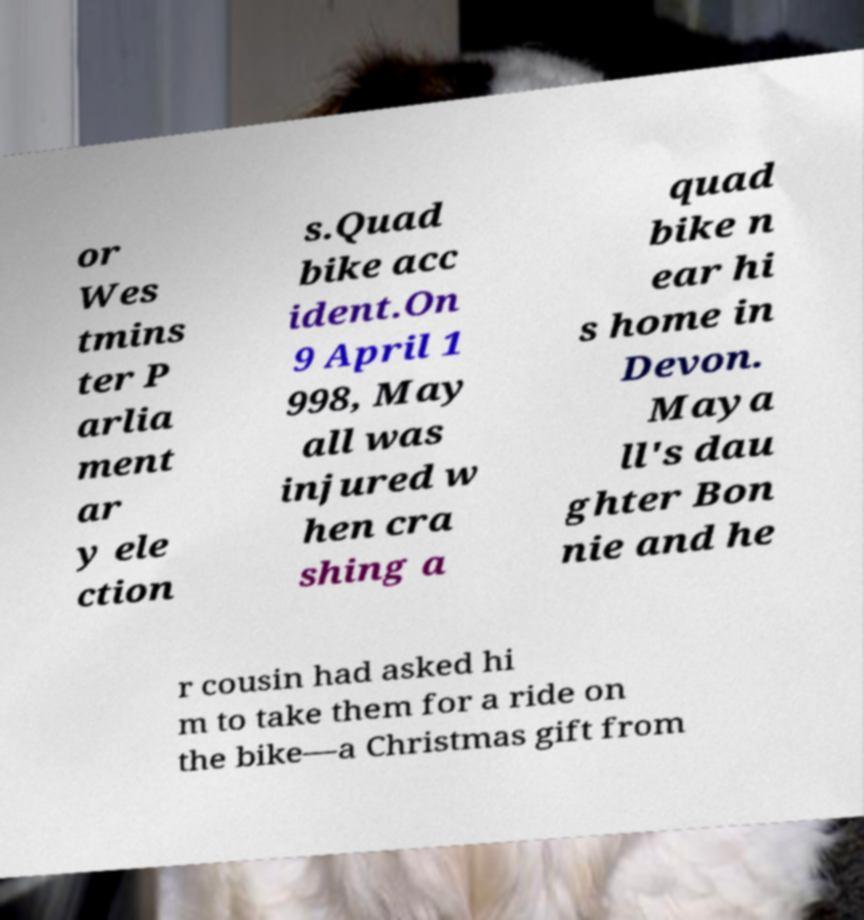Please identify and transcribe the text found in this image. or Wes tmins ter P arlia ment ar y ele ction s.Quad bike acc ident.On 9 April 1 998, May all was injured w hen cra shing a quad bike n ear hi s home in Devon. Maya ll's dau ghter Bon nie and he r cousin had asked hi m to take them for a ride on the bike—a Christmas gift from 